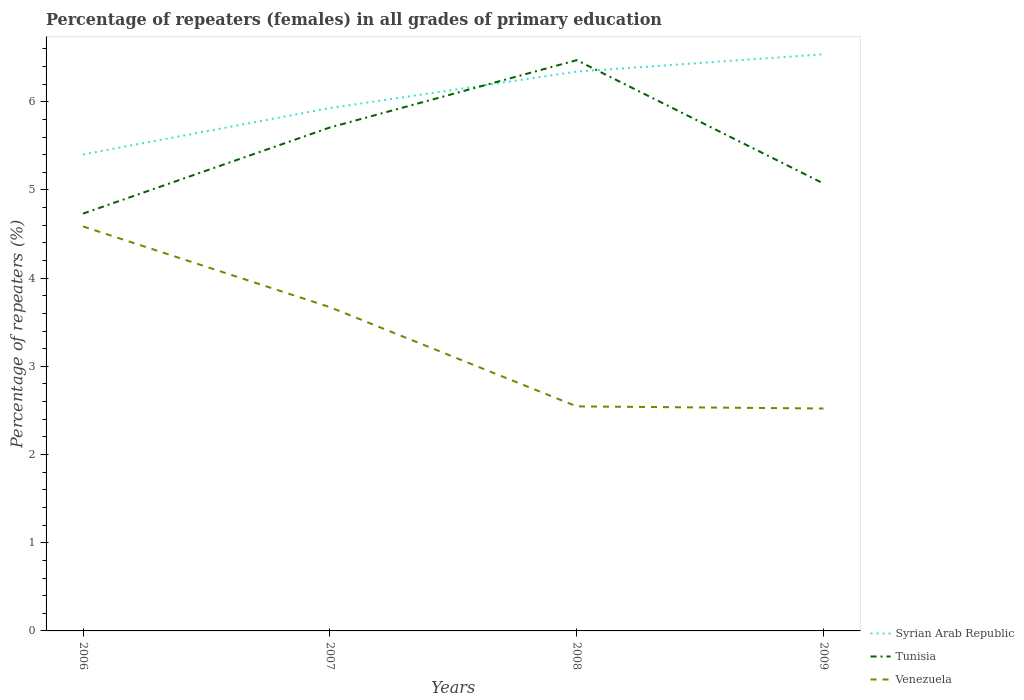How many different coloured lines are there?
Keep it short and to the point. 3. Is the number of lines equal to the number of legend labels?
Provide a succinct answer. Yes. Across all years, what is the maximum percentage of repeaters (females) in Syrian Arab Republic?
Provide a succinct answer. 5.4. What is the total percentage of repeaters (females) in Tunisia in the graph?
Keep it short and to the point. 1.4. What is the difference between the highest and the second highest percentage of repeaters (females) in Tunisia?
Your response must be concise. 1.74. What is the difference between the highest and the lowest percentage of repeaters (females) in Tunisia?
Provide a succinct answer. 2. Is the percentage of repeaters (females) in Venezuela strictly greater than the percentage of repeaters (females) in Syrian Arab Republic over the years?
Your answer should be compact. Yes. What is the difference between two consecutive major ticks on the Y-axis?
Offer a terse response. 1. Where does the legend appear in the graph?
Provide a short and direct response. Bottom right. What is the title of the graph?
Your response must be concise. Percentage of repeaters (females) in all grades of primary education. Does "South Africa" appear as one of the legend labels in the graph?
Provide a short and direct response. No. What is the label or title of the X-axis?
Offer a very short reply. Years. What is the label or title of the Y-axis?
Make the answer very short. Percentage of repeaters (%). What is the Percentage of repeaters (%) of Syrian Arab Republic in 2006?
Your answer should be compact. 5.4. What is the Percentage of repeaters (%) in Tunisia in 2006?
Ensure brevity in your answer.  4.73. What is the Percentage of repeaters (%) in Venezuela in 2006?
Offer a very short reply. 4.59. What is the Percentage of repeaters (%) in Syrian Arab Republic in 2007?
Keep it short and to the point. 5.93. What is the Percentage of repeaters (%) of Tunisia in 2007?
Provide a short and direct response. 5.71. What is the Percentage of repeaters (%) of Venezuela in 2007?
Provide a succinct answer. 3.67. What is the Percentage of repeaters (%) in Syrian Arab Republic in 2008?
Offer a terse response. 6.34. What is the Percentage of repeaters (%) of Tunisia in 2008?
Your answer should be very brief. 6.47. What is the Percentage of repeaters (%) in Venezuela in 2008?
Offer a terse response. 2.55. What is the Percentage of repeaters (%) of Syrian Arab Republic in 2009?
Provide a succinct answer. 6.54. What is the Percentage of repeaters (%) of Tunisia in 2009?
Your response must be concise. 5.07. What is the Percentage of repeaters (%) in Venezuela in 2009?
Offer a terse response. 2.52. Across all years, what is the maximum Percentage of repeaters (%) in Syrian Arab Republic?
Give a very brief answer. 6.54. Across all years, what is the maximum Percentage of repeaters (%) of Tunisia?
Your answer should be very brief. 6.47. Across all years, what is the maximum Percentage of repeaters (%) of Venezuela?
Ensure brevity in your answer.  4.59. Across all years, what is the minimum Percentage of repeaters (%) of Syrian Arab Republic?
Your response must be concise. 5.4. Across all years, what is the minimum Percentage of repeaters (%) of Tunisia?
Your response must be concise. 4.73. Across all years, what is the minimum Percentage of repeaters (%) of Venezuela?
Give a very brief answer. 2.52. What is the total Percentage of repeaters (%) of Syrian Arab Republic in the graph?
Make the answer very short. 24.21. What is the total Percentage of repeaters (%) in Tunisia in the graph?
Your answer should be compact. 21.99. What is the total Percentage of repeaters (%) of Venezuela in the graph?
Provide a short and direct response. 13.33. What is the difference between the Percentage of repeaters (%) in Syrian Arab Republic in 2006 and that in 2007?
Your answer should be very brief. -0.53. What is the difference between the Percentage of repeaters (%) of Tunisia in 2006 and that in 2007?
Provide a short and direct response. -0.98. What is the difference between the Percentage of repeaters (%) in Venezuela in 2006 and that in 2007?
Ensure brevity in your answer.  0.92. What is the difference between the Percentage of repeaters (%) of Syrian Arab Republic in 2006 and that in 2008?
Provide a succinct answer. -0.94. What is the difference between the Percentage of repeaters (%) of Tunisia in 2006 and that in 2008?
Give a very brief answer. -1.74. What is the difference between the Percentage of repeaters (%) in Venezuela in 2006 and that in 2008?
Ensure brevity in your answer.  2.04. What is the difference between the Percentage of repeaters (%) in Syrian Arab Republic in 2006 and that in 2009?
Keep it short and to the point. -1.14. What is the difference between the Percentage of repeaters (%) in Tunisia in 2006 and that in 2009?
Provide a succinct answer. -0.34. What is the difference between the Percentage of repeaters (%) of Venezuela in 2006 and that in 2009?
Provide a short and direct response. 2.06. What is the difference between the Percentage of repeaters (%) of Syrian Arab Republic in 2007 and that in 2008?
Your answer should be compact. -0.41. What is the difference between the Percentage of repeaters (%) of Tunisia in 2007 and that in 2008?
Offer a terse response. -0.76. What is the difference between the Percentage of repeaters (%) of Venezuela in 2007 and that in 2008?
Provide a succinct answer. 1.13. What is the difference between the Percentage of repeaters (%) in Syrian Arab Republic in 2007 and that in 2009?
Provide a short and direct response. -0.61. What is the difference between the Percentage of repeaters (%) in Tunisia in 2007 and that in 2009?
Your answer should be compact. 0.63. What is the difference between the Percentage of repeaters (%) in Venezuela in 2007 and that in 2009?
Give a very brief answer. 1.15. What is the difference between the Percentage of repeaters (%) in Syrian Arab Republic in 2008 and that in 2009?
Ensure brevity in your answer.  -0.2. What is the difference between the Percentage of repeaters (%) in Tunisia in 2008 and that in 2009?
Your answer should be very brief. 1.4. What is the difference between the Percentage of repeaters (%) in Venezuela in 2008 and that in 2009?
Your answer should be very brief. 0.02. What is the difference between the Percentage of repeaters (%) in Syrian Arab Republic in 2006 and the Percentage of repeaters (%) in Tunisia in 2007?
Offer a terse response. -0.31. What is the difference between the Percentage of repeaters (%) in Syrian Arab Republic in 2006 and the Percentage of repeaters (%) in Venezuela in 2007?
Provide a succinct answer. 1.73. What is the difference between the Percentage of repeaters (%) in Tunisia in 2006 and the Percentage of repeaters (%) in Venezuela in 2007?
Give a very brief answer. 1.06. What is the difference between the Percentage of repeaters (%) of Syrian Arab Republic in 2006 and the Percentage of repeaters (%) of Tunisia in 2008?
Your answer should be very brief. -1.07. What is the difference between the Percentage of repeaters (%) in Syrian Arab Republic in 2006 and the Percentage of repeaters (%) in Venezuela in 2008?
Give a very brief answer. 2.86. What is the difference between the Percentage of repeaters (%) of Tunisia in 2006 and the Percentage of repeaters (%) of Venezuela in 2008?
Provide a succinct answer. 2.19. What is the difference between the Percentage of repeaters (%) of Syrian Arab Republic in 2006 and the Percentage of repeaters (%) of Tunisia in 2009?
Provide a short and direct response. 0.33. What is the difference between the Percentage of repeaters (%) of Syrian Arab Republic in 2006 and the Percentage of repeaters (%) of Venezuela in 2009?
Your answer should be very brief. 2.88. What is the difference between the Percentage of repeaters (%) in Tunisia in 2006 and the Percentage of repeaters (%) in Venezuela in 2009?
Ensure brevity in your answer.  2.21. What is the difference between the Percentage of repeaters (%) in Syrian Arab Republic in 2007 and the Percentage of repeaters (%) in Tunisia in 2008?
Provide a short and direct response. -0.54. What is the difference between the Percentage of repeaters (%) in Syrian Arab Republic in 2007 and the Percentage of repeaters (%) in Venezuela in 2008?
Your answer should be compact. 3.38. What is the difference between the Percentage of repeaters (%) in Tunisia in 2007 and the Percentage of repeaters (%) in Venezuela in 2008?
Offer a terse response. 3.16. What is the difference between the Percentage of repeaters (%) of Syrian Arab Republic in 2007 and the Percentage of repeaters (%) of Tunisia in 2009?
Your response must be concise. 0.86. What is the difference between the Percentage of repeaters (%) of Syrian Arab Republic in 2007 and the Percentage of repeaters (%) of Venezuela in 2009?
Provide a short and direct response. 3.41. What is the difference between the Percentage of repeaters (%) of Tunisia in 2007 and the Percentage of repeaters (%) of Venezuela in 2009?
Your response must be concise. 3.19. What is the difference between the Percentage of repeaters (%) in Syrian Arab Republic in 2008 and the Percentage of repeaters (%) in Tunisia in 2009?
Your response must be concise. 1.27. What is the difference between the Percentage of repeaters (%) of Syrian Arab Republic in 2008 and the Percentage of repeaters (%) of Venezuela in 2009?
Ensure brevity in your answer.  3.82. What is the difference between the Percentage of repeaters (%) in Tunisia in 2008 and the Percentage of repeaters (%) in Venezuela in 2009?
Ensure brevity in your answer.  3.95. What is the average Percentage of repeaters (%) of Syrian Arab Republic per year?
Offer a very short reply. 6.05. What is the average Percentage of repeaters (%) in Tunisia per year?
Your response must be concise. 5.5. What is the average Percentage of repeaters (%) of Venezuela per year?
Your answer should be very brief. 3.33. In the year 2006, what is the difference between the Percentage of repeaters (%) in Syrian Arab Republic and Percentage of repeaters (%) in Tunisia?
Your response must be concise. 0.67. In the year 2006, what is the difference between the Percentage of repeaters (%) of Syrian Arab Republic and Percentage of repeaters (%) of Venezuela?
Provide a short and direct response. 0.82. In the year 2006, what is the difference between the Percentage of repeaters (%) of Tunisia and Percentage of repeaters (%) of Venezuela?
Provide a succinct answer. 0.15. In the year 2007, what is the difference between the Percentage of repeaters (%) in Syrian Arab Republic and Percentage of repeaters (%) in Tunisia?
Make the answer very short. 0.22. In the year 2007, what is the difference between the Percentage of repeaters (%) of Syrian Arab Republic and Percentage of repeaters (%) of Venezuela?
Provide a succinct answer. 2.26. In the year 2007, what is the difference between the Percentage of repeaters (%) of Tunisia and Percentage of repeaters (%) of Venezuela?
Provide a short and direct response. 2.04. In the year 2008, what is the difference between the Percentage of repeaters (%) of Syrian Arab Republic and Percentage of repeaters (%) of Tunisia?
Your answer should be very brief. -0.13. In the year 2008, what is the difference between the Percentage of repeaters (%) of Syrian Arab Republic and Percentage of repeaters (%) of Venezuela?
Offer a very short reply. 3.8. In the year 2008, what is the difference between the Percentage of repeaters (%) of Tunisia and Percentage of repeaters (%) of Venezuela?
Your response must be concise. 3.93. In the year 2009, what is the difference between the Percentage of repeaters (%) in Syrian Arab Republic and Percentage of repeaters (%) in Tunisia?
Keep it short and to the point. 1.46. In the year 2009, what is the difference between the Percentage of repeaters (%) in Syrian Arab Republic and Percentage of repeaters (%) in Venezuela?
Provide a short and direct response. 4.02. In the year 2009, what is the difference between the Percentage of repeaters (%) in Tunisia and Percentage of repeaters (%) in Venezuela?
Offer a very short reply. 2.55. What is the ratio of the Percentage of repeaters (%) in Syrian Arab Republic in 2006 to that in 2007?
Provide a succinct answer. 0.91. What is the ratio of the Percentage of repeaters (%) of Tunisia in 2006 to that in 2007?
Your response must be concise. 0.83. What is the ratio of the Percentage of repeaters (%) of Venezuela in 2006 to that in 2007?
Provide a succinct answer. 1.25. What is the ratio of the Percentage of repeaters (%) in Syrian Arab Republic in 2006 to that in 2008?
Provide a short and direct response. 0.85. What is the ratio of the Percentage of repeaters (%) in Tunisia in 2006 to that in 2008?
Your answer should be very brief. 0.73. What is the ratio of the Percentage of repeaters (%) in Venezuela in 2006 to that in 2008?
Offer a very short reply. 1.8. What is the ratio of the Percentage of repeaters (%) in Syrian Arab Republic in 2006 to that in 2009?
Make the answer very short. 0.83. What is the ratio of the Percentage of repeaters (%) in Tunisia in 2006 to that in 2009?
Provide a succinct answer. 0.93. What is the ratio of the Percentage of repeaters (%) in Venezuela in 2006 to that in 2009?
Provide a succinct answer. 1.82. What is the ratio of the Percentage of repeaters (%) of Syrian Arab Republic in 2007 to that in 2008?
Provide a short and direct response. 0.93. What is the ratio of the Percentage of repeaters (%) of Tunisia in 2007 to that in 2008?
Offer a terse response. 0.88. What is the ratio of the Percentage of repeaters (%) of Venezuela in 2007 to that in 2008?
Your response must be concise. 1.44. What is the ratio of the Percentage of repeaters (%) of Syrian Arab Republic in 2007 to that in 2009?
Provide a short and direct response. 0.91. What is the ratio of the Percentage of repeaters (%) in Tunisia in 2007 to that in 2009?
Your response must be concise. 1.13. What is the ratio of the Percentage of repeaters (%) in Venezuela in 2007 to that in 2009?
Make the answer very short. 1.46. What is the ratio of the Percentage of repeaters (%) in Syrian Arab Republic in 2008 to that in 2009?
Provide a succinct answer. 0.97. What is the ratio of the Percentage of repeaters (%) of Tunisia in 2008 to that in 2009?
Make the answer very short. 1.28. What is the ratio of the Percentage of repeaters (%) of Venezuela in 2008 to that in 2009?
Your answer should be compact. 1.01. What is the difference between the highest and the second highest Percentage of repeaters (%) in Syrian Arab Republic?
Provide a short and direct response. 0.2. What is the difference between the highest and the second highest Percentage of repeaters (%) in Tunisia?
Make the answer very short. 0.76. What is the difference between the highest and the second highest Percentage of repeaters (%) of Venezuela?
Your answer should be compact. 0.92. What is the difference between the highest and the lowest Percentage of repeaters (%) in Syrian Arab Republic?
Give a very brief answer. 1.14. What is the difference between the highest and the lowest Percentage of repeaters (%) of Tunisia?
Your answer should be compact. 1.74. What is the difference between the highest and the lowest Percentage of repeaters (%) of Venezuela?
Provide a succinct answer. 2.06. 